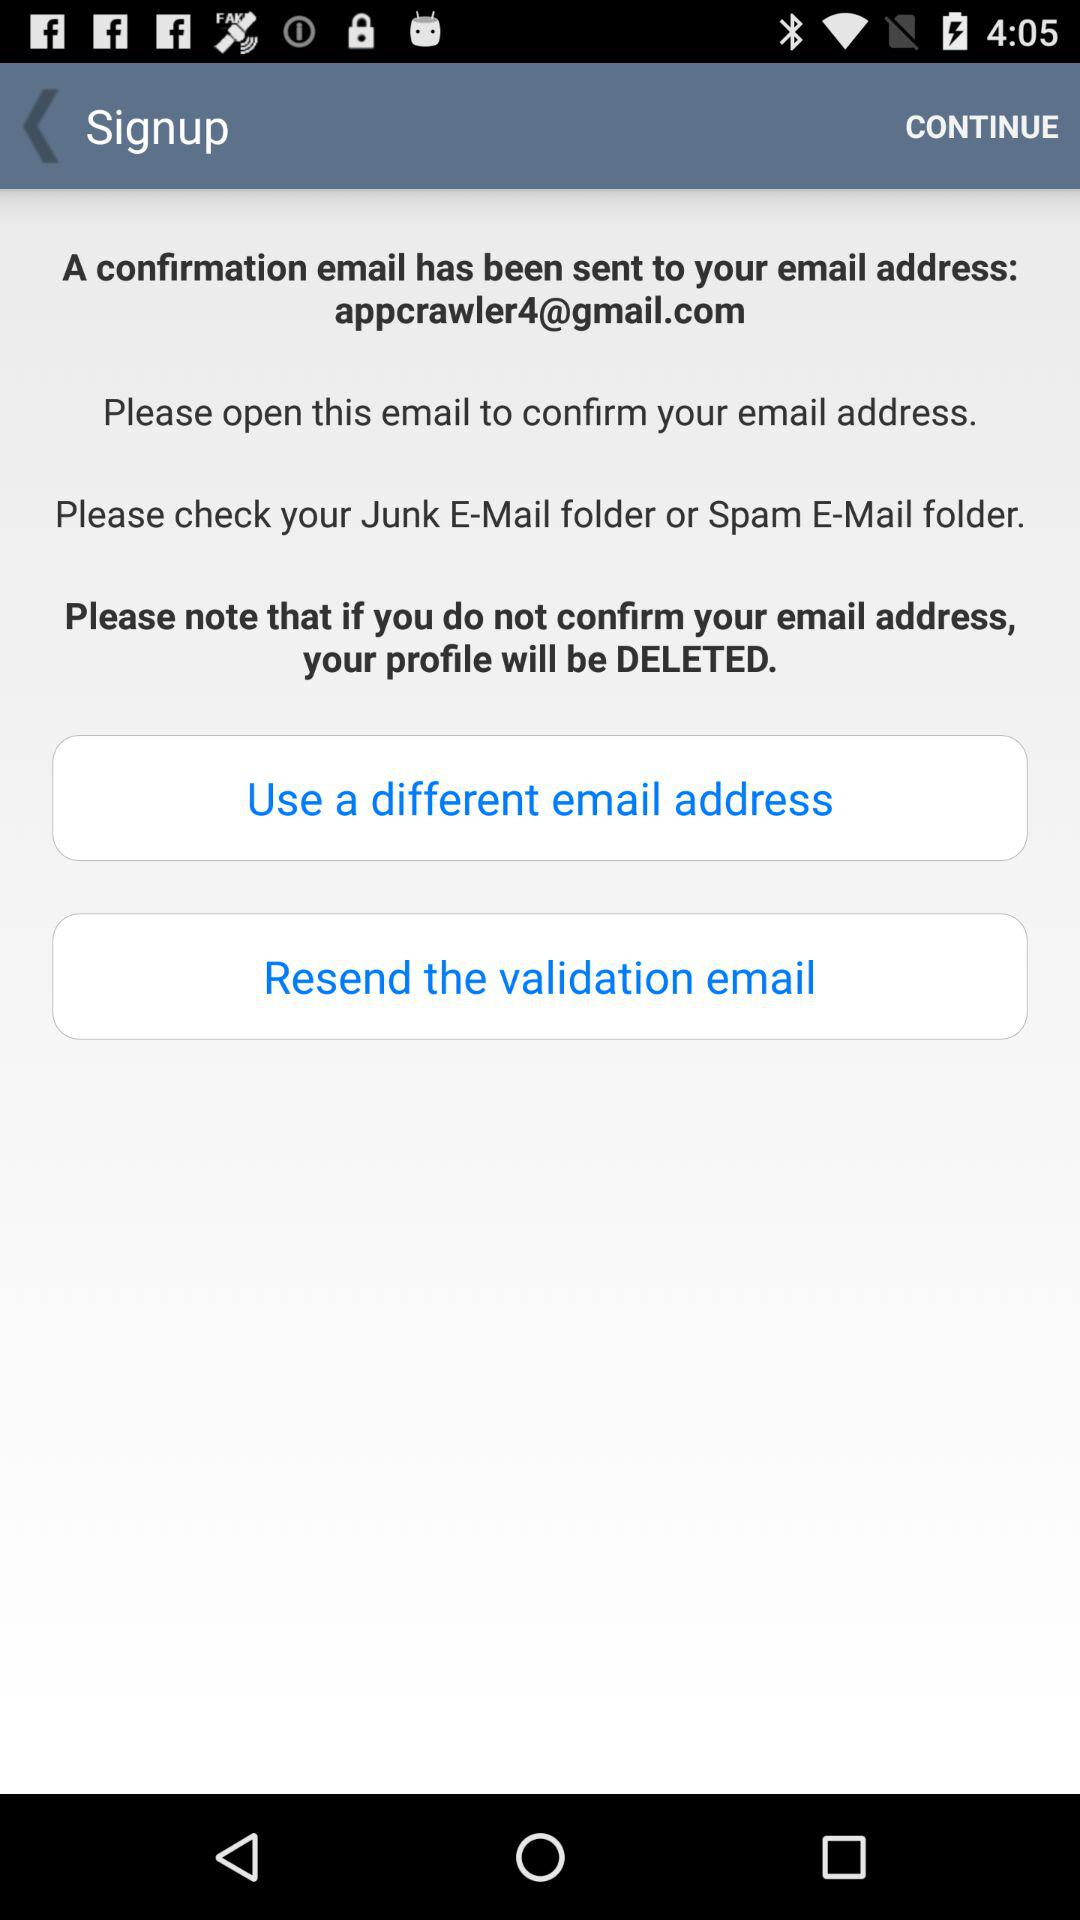What is the email address? The email address is appcrawler4@gmail.com. 